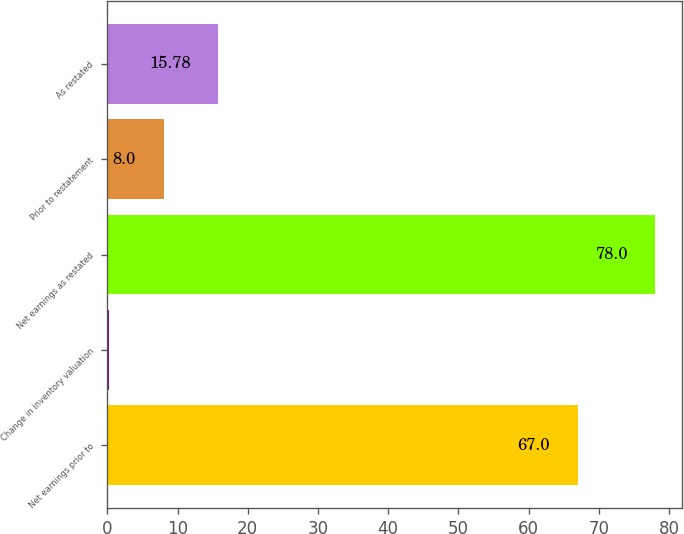Convert chart. <chart><loc_0><loc_0><loc_500><loc_500><bar_chart><fcel>Net earnings prior to<fcel>Change in inventory valuation<fcel>Net earnings as restated<fcel>Prior to restatement<fcel>As restated<nl><fcel>67<fcel>0.22<fcel>78<fcel>8<fcel>15.78<nl></chart> 